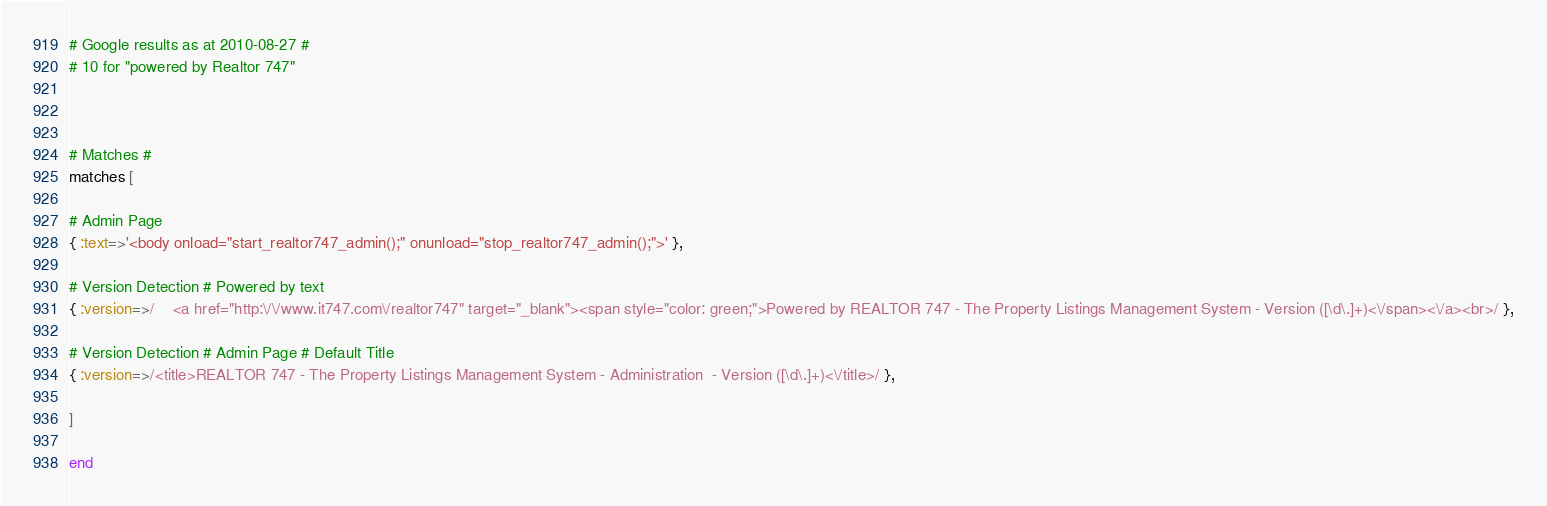<code> <loc_0><loc_0><loc_500><loc_500><_Ruby_>
# Google results as at 2010-08-27 #
# 10 for "powered by Realtor 747"



# Matches #
matches [

# Admin Page
{ :text=>'<body onload="start_realtor747_admin();" onunload="stop_realtor747_admin();">' },

# Version Detection # Powered by text
{ :version=>/    <a href="http:\/\/www.it747.com\/realtor747" target="_blank"><span style="color: green;">Powered by REALTOR 747 - The Property Listings Management System - Version ([\d\.]+)<\/span><\/a><br>/ },

# Version Detection # Admin Page # Default Title
{ :version=>/<title>REALTOR 747 - The Property Listings Management System - Administration  - Version ([\d\.]+)<\/title>/ },

]

end


</code> 